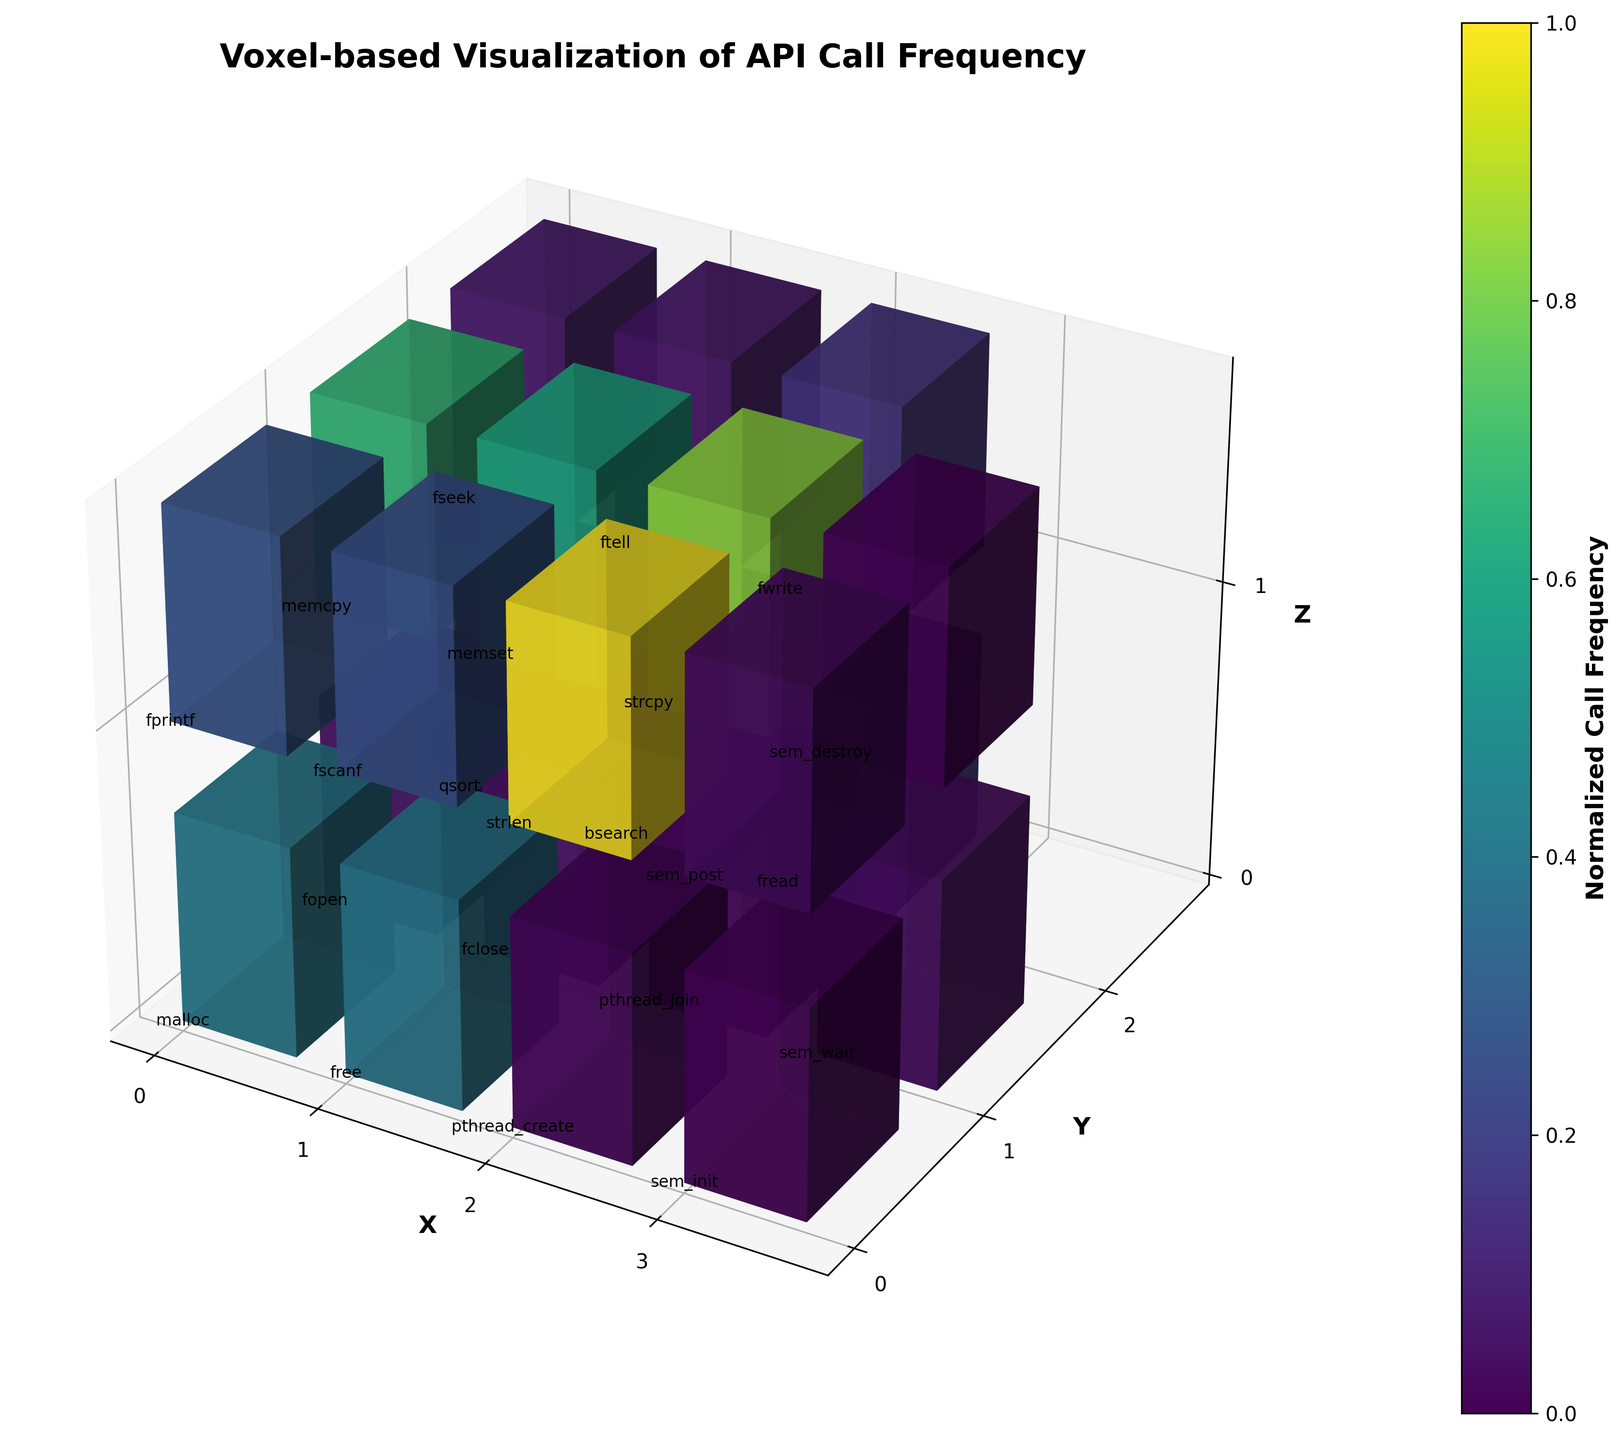How many axes are labeled in the plot? The plot has three labeled axes as indicated by the labels: 'X', 'Y', and 'Z' at their respective positions.
Answer: Three Which function has the highest number of API calls and what is the value? The function with the highest number of API calls appears as one of the largest bars in the plot. On examining the plot, 'strlen' located at (2, 0, 1) has the highest bar with a call frequency of 3000.
Answer: 'strlen', 3000 Which axis has the title 'Normalized Call Frequency'? The title 'Normalized Call Frequency' appears on the color bar to the right of the plot, and it represents the color coding of the calls frequency.
Answer: Color bar What is the total API call frequency for the functions at the coordinate (3, 1, 0) and (3, 0, 1)? The plot shows 'sem_wait' at (3, 1, 0) with 100 calls and 'sem_post' at (3, 0, 1) also with 100 calls. Summing them gives 100 + 100 = 200.
Answer: 200 Which has more API calls: 'fprintf' or 'fscanf'? By comparing the heights of the bars for 'fprintf' at (0, 0, 1) and 'fscanf' at (1, 0, 1), 'fprintf' has 800 calls, and 'fscanf' has 750 calls. 'fprintf' has more calls.
Answer: 'fprintf' How many functions have an API call frequency above 1000? Examine the height of the bars and the annotations beside them. 'malloc' (1250), 'memcpy' (2000), 'memset' (1800), 'strlen' (3000), and 'strcpy' (2500) are above 1000. Count the annotations: 5 functions.
Answer: Five Which Z-plane has the highest cumulative call frequency? Sum the API calls for each Z-plane. Z=0: 1250 + 1200 + 150 + 148 + 50 + 50 + 75 + 30 + 500 + 25 + 100. Z=1: 800 + 750 + 2000 + 1800 + 3000 + 2500 + 200 + 180 + 450 + 100 + 25. Totals: Z=0 is 3578, Z=1 is 9805.
Answer: Z=1 What color represents the highest call frequency? The highest call frequency, which is 3000 for 'strlen', would be the darkest color in the viridis colormap used in the plot. Examining the color bar shows the darkest color represents the highest call frequency.
Answer: Darkest color Is the function 'fread' called more frequently than 'fopen'? By comparing the bars for 'fread' at (2, 2, 0) and 'fopen' at (0, 1, 0), 'fread' has 500 calls while 'fopen' has 150 calls. 'fread' has more calls.
Answer: Yes Which functions are located at the coordinates (0, 1, 1) and (1, 1, 0), and what are their respective call frequencies? The function at (0, 1, 1) is 'memcpy' with 2000 calls, and the function at (1, 1, 0) is 'fclose' with 148 calls.
Answer: 'memcpy': 2000, 'fclose': 148 